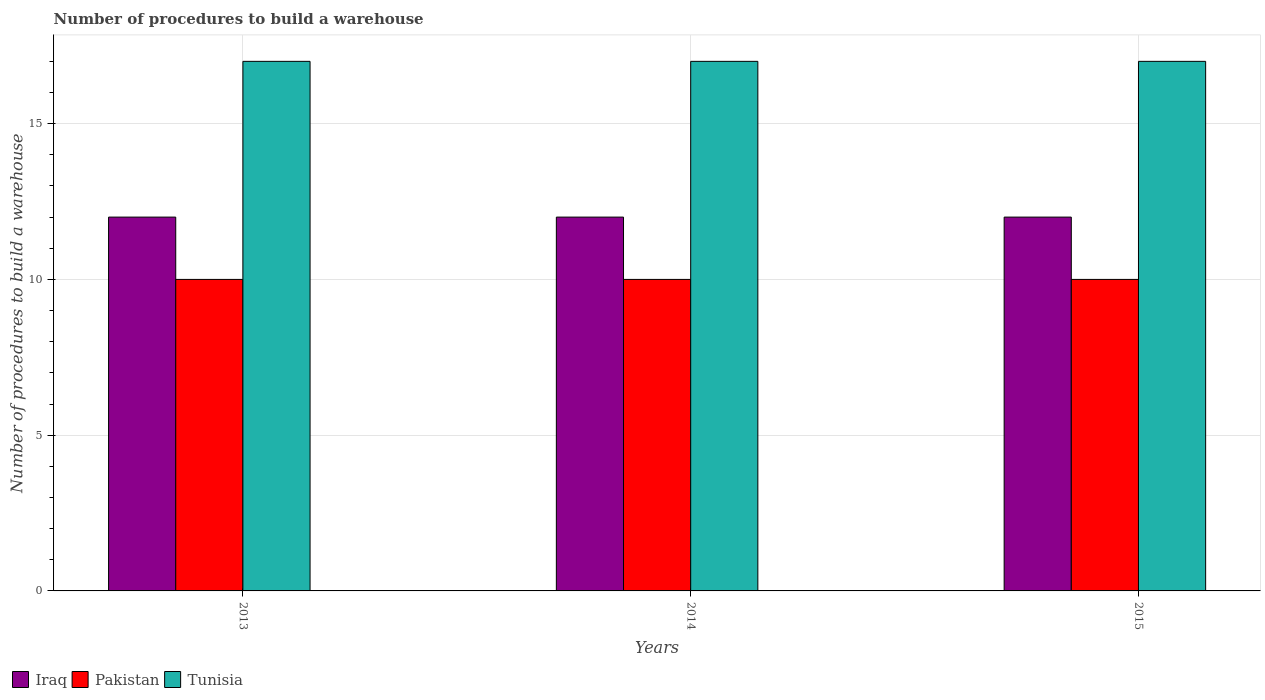How many different coloured bars are there?
Provide a short and direct response. 3. Are the number of bars per tick equal to the number of legend labels?
Your answer should be very brief. Yes. Are the number of bars on each tick of the X-axis equal?
Your answer should be very brief. Yes. How many bars are there on the 3rd tick from the right?
Offer a very short reply. 3. In how many cases, is the number of bars for a given year not equal to the number of legend labels?
Provide a succinct answer. 0. What is the number of procedures to build a warehouse in in Tunisia in 2014?
Provide a short and direct response. 17. Across all years, what is the maximum number of procedures to build a warehouse in in Tunisia?
Provide a short and direct response. 17. Across all years, what is the minimum number of procedures to build a warehouse in in Pakistan?
Keep it short and to the point. 10. In which year was the number of procedures to build a warehouse in in Tunisia maximum?
Your response must be concise. 2013. What is the total number of procedures to build a warehouse in in Iraq in the graph?
Your response must be concise. 36. What is the difference between the number of procedures to build a warehouse in in Tunisia in 2014 and the number of procedures to build a warehouse in in Iraq in 2013?
Ensure brevity in your answer.  5. What is the average number of procedures to build a warehouse in in Tunisia per year?
Ensure brevity in your answer.  17. In how many years, is the number of procedures to build a warehouse in in Iraq greater than 12?
Make the answer very short. 0. What is the ratio of the number of procedures to build a warehouse in in Pakistan in 2013 to that in 2015?
Offer a terse response. 1. What is the difference between the highest and the lowest number of procedures to build a warehouse in in Pakistan?
Your response must be concise. 0. In how many years, is the number of procedures to build a warehouse in in Pakistan greater than the average number of procedures to build a warehouse in in Pakistan taken over all years?
Ensure brevity in your answer.  0. What does the 3rd bar from the left in 2014 represents?
Ensure brevity in your answer.  Tunisia. What does the 3rd bar from the right in 2015 represents?
Offer a very short reply. Iraq. Are all the bars in the graph horizontal?
Provide a short and direct response. No. Are the values on the major ticks of Y-axis written in scientific E-notation?
Keep it short and to the point. No. Does the graph contain any zero values?
Offer a very short reply. No. Does the graph contain grids?
Your answer should be compact. Yes. What is the title of the graph?
Offer a very short reply. Number of procedures to build a warehouse. Does "Cote d'Ivoire" appear as one of the legend labels in the graph?
Keep it short and to the point. No. What is the label or title of the Y-axis?
Offer a very short reply. Number of procedures to build a warehouse. What is the Number of procedures to build a warehouse in Pakistan in 2013?
Make the answer very short. 10. What is the Number of procedures to build a warehouse of Tunisia in 2013?
Offer a very short reply. 17. What is the Number of procedures to build a warehouse of Pakistan in 2014?
Offer a very short reply. 10. What is the Number of procedures to build a warehouse in Iraq in 2015?
Give a very brief answer. 12. What is the Number of procedures to build a warehouse in Pakistan in 2015?
Give a very brief answer. 10. Across all years, what is the maximum Number of procedures to build a warehouse of Pakistan?
Provide a succinct answer. 10. Across all years, what is the minimum Number of procedures to build a warehouse of Iraq?
Offer a terse response. 12. What is the total Number of procedures to build a warehouse in Iraq in the graph?
Offer a terse response. 36. What is the total Number of procedures to build a warehouse in Pakistan in the graph?
Provide a succinct answer. 30. What is the total Number of procedures to build a warehouse of Tunisia in the graph?
Provide a succinct answer. 51. What is the difference between the Number of procedures to build a warehouse of Pakistan in 2013 and that in 2015?
Your answer should be compact. 0. What is the difference between the Number of procedures to build a warehouse in Tunisia in 2014 and that in 2015?
Ensure brevity in your answer.  0. What is the difference between the Number of procedures to build a warehouse in Pakistan in 2013 and the Number of procedures to build a warehouse in Tunisia in 2014?
Ensure brevity in your answer.  -7. What is the difference between the Number of procedures to build a warehouse in Iraq in 2013 and the Number of procedures to build a warehouse in Pakistan in 2015?
Make the answer very short. 2. What is the average Number of procedures to build a warehouse of Iraq per year?
Provide a short and direct response. 12. What is the average Number of procedures to build a warehouse in Pakistan per year?
Your response must be concise. 10. What is the average Number of procedures to build a warehouse of Tunisia per year?
Ensure brevity in your answer.  17. In the year 2013, what is the difference between the Number of procedures to build a warehouse in Iraq and Number of procedures to build a warehouse in Tunisia?
Provide a short and direct response. -5. In the year 2014, what is the difference between the Number of procedures to build a warehouse of Iraq and Number of procedures to build a warehouse of Tunisia?
Your response must be concise. -5. In the year 2015, what is the difference between the Number of procedures to build a warehouse in Iraq and Number of procedures to build a warehouse in Pakistan?
Ensure brevity in your answer.  2. In the year 2015, what is the difference between the Number of procedures to build a warehouse in Iraq and Number of procedures to build a warehouse in Tunisia?
Offer a terse response. -5. In the year 2015, what is the difference between the Number of procedures to build a warehouse of Pakistan and Number of procedures to build a warehouse of Tunisia?
Give a very brief answer. -7. What is the ratio of the Number of procedures to build a warehouse of Iraq in 2013 to that in 2015?
Your answer should be compact. 1. What is the ratio of the Number of procedures to build a warehouse of Pakistan in 2013 to that in 2015?
Give a very brief answer. 1. What is the ratio of the Number of procedures to build a warehouse in Iraq in 2014 to that in 2015?
Your answer should be compact. 1. What is the ratio of the Number of procedures to build a warehouse of Tunisia in 2014 to that in 2015?
Offer a very short reply. 1. What is the difference between the highest and the second highest Number of procedures to build a warehouse of Iraq?
Your answer should be compact. 0. What is the difference between the highest and the second highest Number of procedures to build a warehouse of Pakistan?
Your answer should be very brief. 0. What is the difference between the highest and the second highest Number of procedures to build a warehouse of Tunisia?
Provide a short and direct response. 0. What is the difference between the highest and the lowest Number of procedures to build a warehouse of Pakistan?
Offer a terse response. 0. 